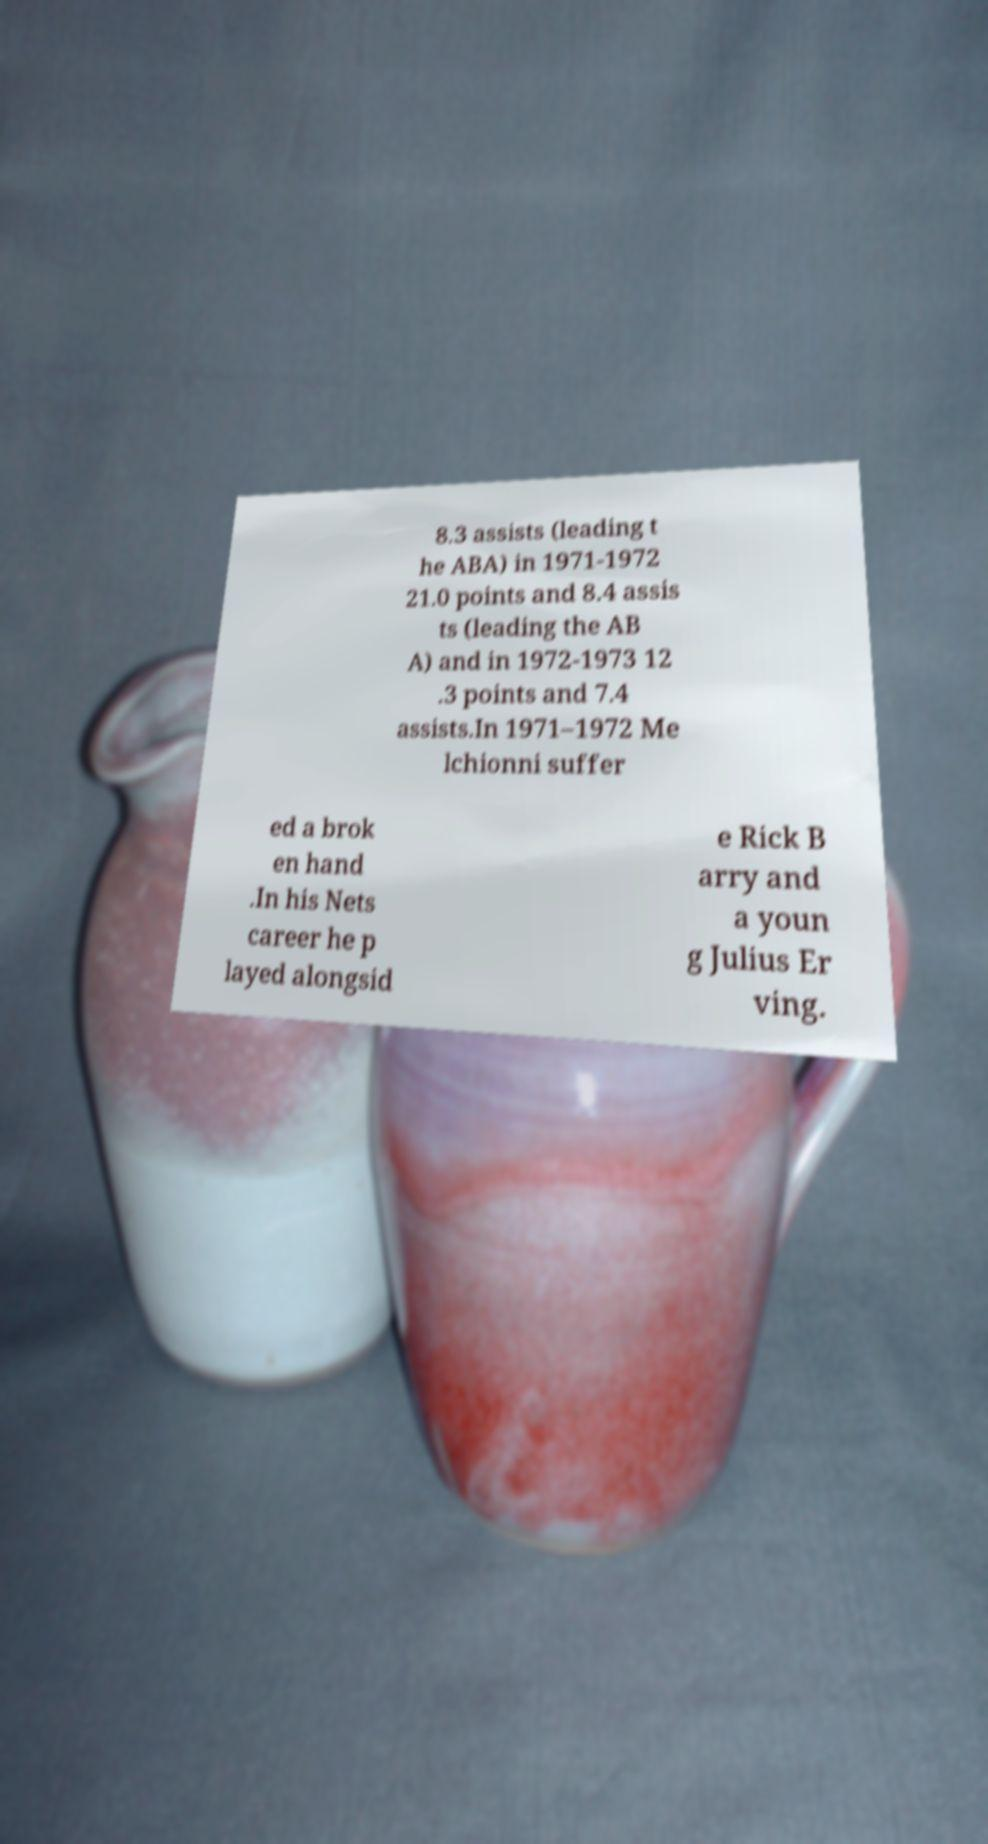Could you assist in decoding the text presented in this image and type it out clearly? 8.3 assists (leading t he ABA) in 1971-1972 21.0 points and 8.4 assis ts (leading the AB A) and in 1972-1973 12 .3 points and 7.4 assists.In 1971–1972 Me lchionni suffer ed a brok en hand .In his Nets career he p layed alongsid e Rick B arry and a youn g Julius Er ving. 